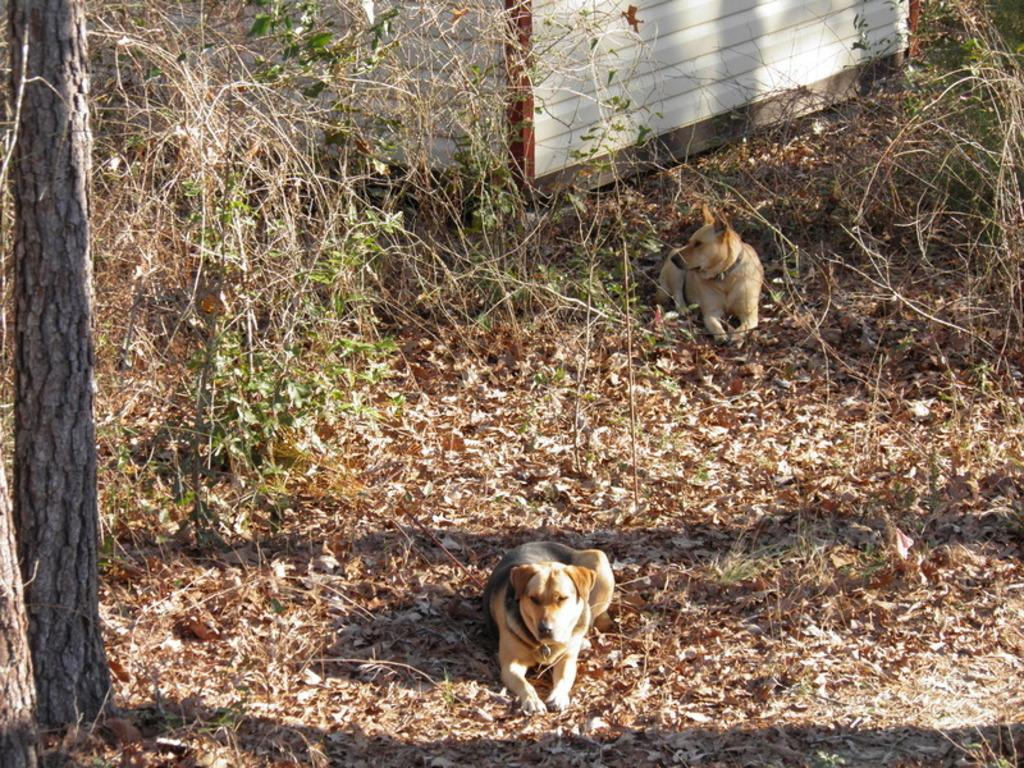What type of animals can be seen in the image? There are dogs in the image. What is the ground made of in the image? Dry grass is visible in the image. What type of vegetation is present in the image? Plants are present in the image. What is the wooden object in the image? There is a wooden pole in the image. What type of structure is visible in the image? There is a wall in the image. Reasoning: Let' Let's think step by step in order to produce the conversation. We start by identifying the main subject in the image, which is the dogs. Then, we expand the conversation to include other elements of the image, such as the dry grass, plants, wooden pole, and wall. Each question is designed to elicit a specific detail about the image that is known from the provided facts. Absurd Question/Answer: How does the cast affect the dogs' ability to touch the wooden pole in the image? There is no mention of a cast in the image, so it cannot affect the dogs' ability to touch the wooden pole. 